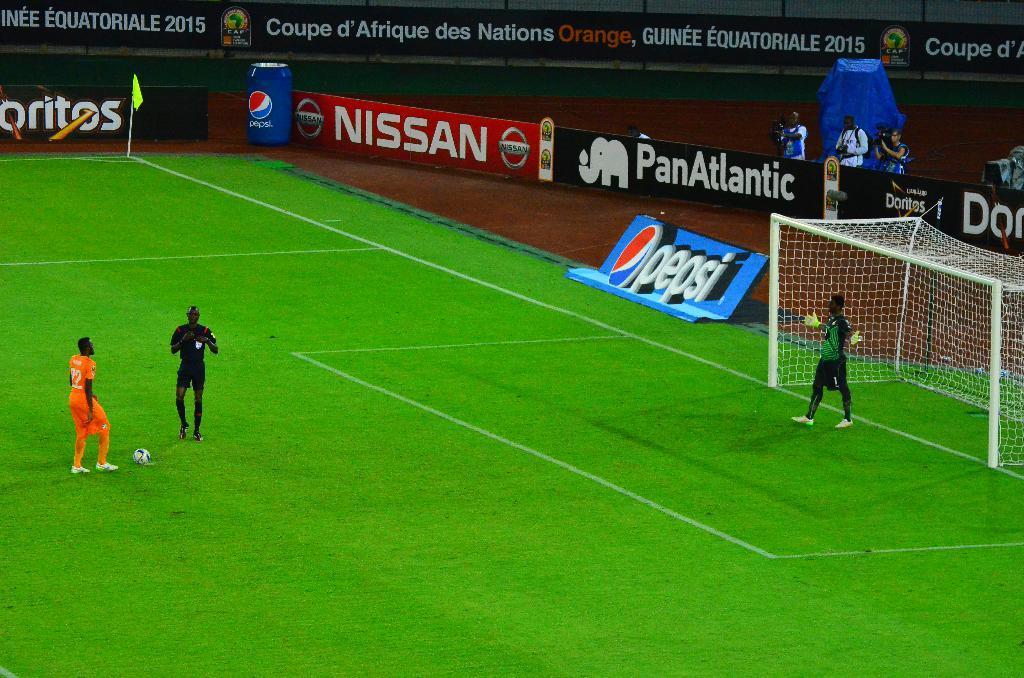Describe this image in one or two sentences. In this picture we can see there are three people and a ball on the ground. On the right side of the people there is a net, poles and boards. Behind the boards, there are three other people standing and holding the cameras. 